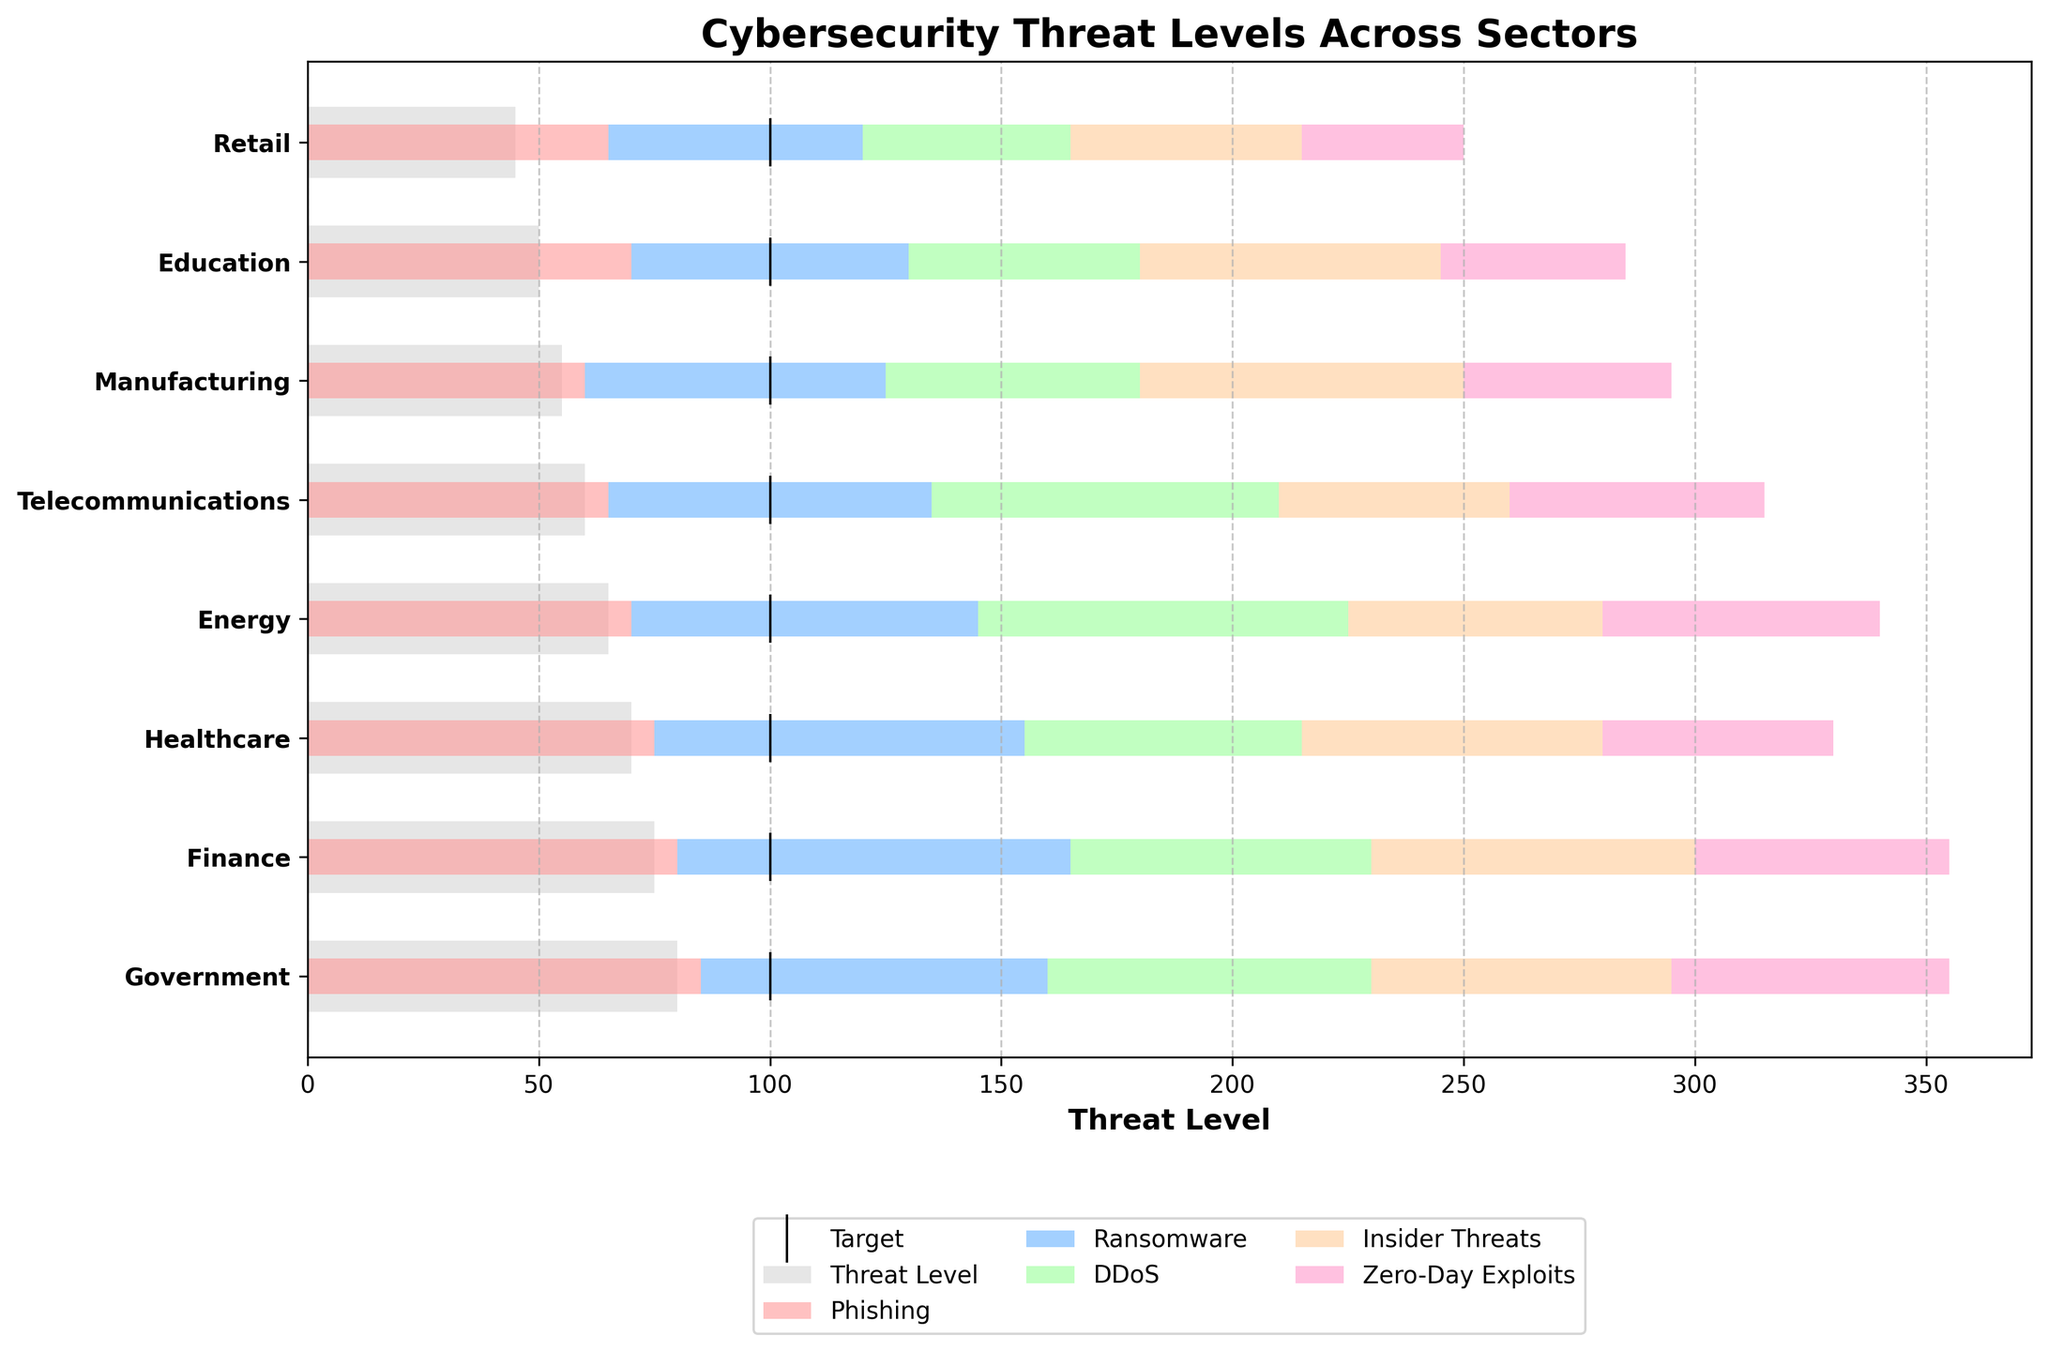What's the title of the figure? The title of the figure is shown at the top of the plot.
Answer: Cybersecurity Threat Levels Across Sectors Which sector has the highest threat level indicated by the main bar? The height of the main bar indicates the threat level. The tallest bar corresponds to the Government sector.
Answer: Government What do the vertical markers represent? The vertical markers (black lines) represent the target threat levels for each sector.
Answer: Target threat levels Among all the sectors, which one has the highest value for Zero-Day Exploits? Locate the color representing Zero-Day Exploits and find the longest bar segment in this color.
Answer: Energy What is the difference in the overall threat level between the Government and Retail sectors? Subtract the threat level of Retail from the threat level of Government. Threat level for Government is 80, and for Retail is 45. 80 - 45 = 35.
Answer: 35 Which two sectors have the same target level? Observe the vertical markers across sectors and identify sectors with the same target marker level.
Answer: All sectors (100) How does the healthcare sector compare to the education sector in terms of the sum of Phishing and Ransomware threats? Sum the values of Phishing and Ransomware for Healthcare (75 + 80 = 155) and Education (70 + 60 = 130), then compare the sums. 155 - 130 = 25
Answer: Healthcare is 25 units higher For the finance sector, what is the combined threat level of DDoS and Insider Threats? Add the values of DDoS and Insider Threats for the Finance sector. DDoS is 65 and Insider Threats is 70. 65 + 70 = 135
Answer: 135 Which sector has the lowest threat level in the main bar, and what is its value? Identify the shortest main bar and its corresponding value.
Answer: Retail, 45 In the telecommunications sector, how do the threat levels of Ransomware and Insider Threats compare? Compare the lengths of the Ransomware and Insider Threats bars for the Telecommunications sector. Ransomware is 70 and Insider Threats is 50.
Answer: Ransomware is higher by 20 units 